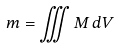Convert formula to latex. <formula><loc_0><loc_0><loc_500><loc_500>m = \iiint M \, d V</formula> 